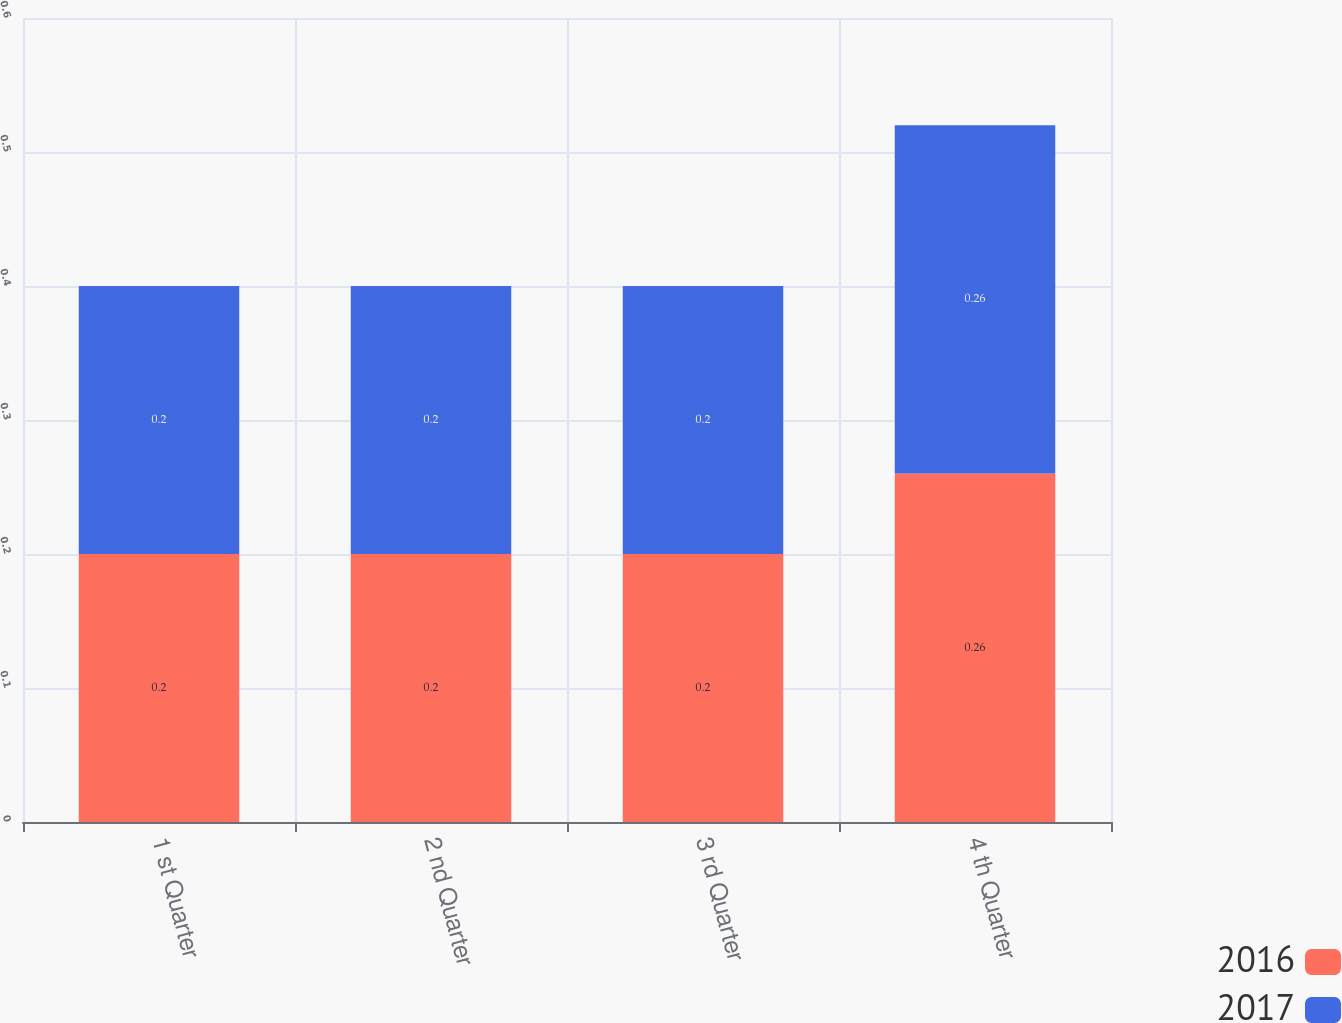<chart> <loc_0><loc_0><loc_500><loc_500><stacked_bar_chart><ecel><fcel>1 st Quarter<fcel>2 nd Quarter<fcel>3 rd Quarter<fcel>4 th Quarter<nl><fcel>2016<fcel>0.2<fcel>0.2<fcel>0.2<fcel>0.26<nl><fcel>2017<fcel>0.2<fcel>0.2<fcel>0.2<fcel>0.26<nl></chart> 